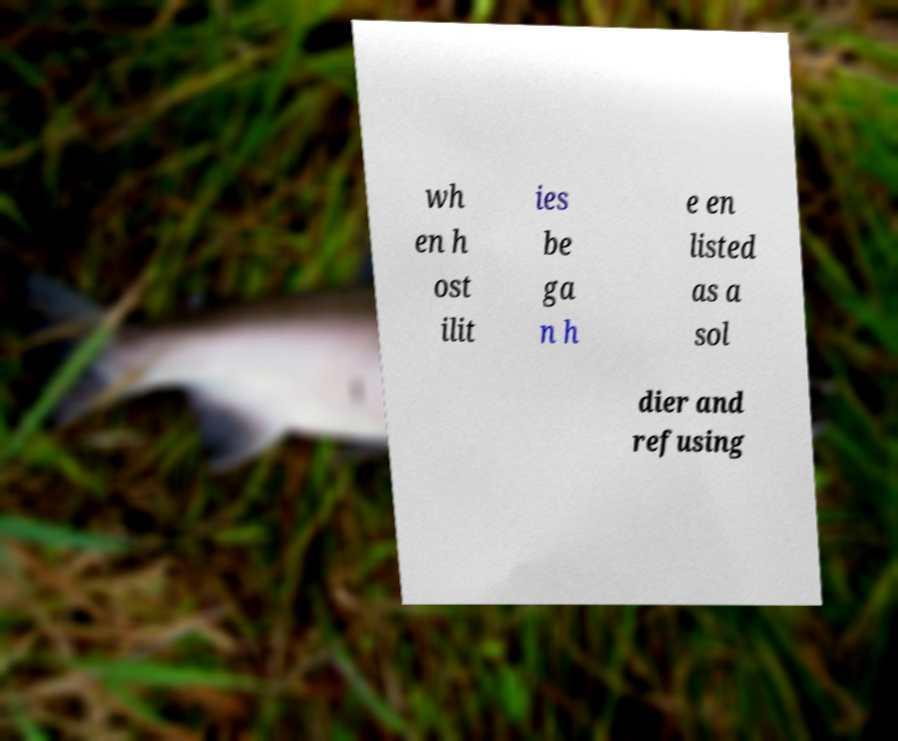I need the written content from this picture converted into text. Can you do that? wh en h ost ilit ies be ga n h e en listed as a sol dier and refusing 